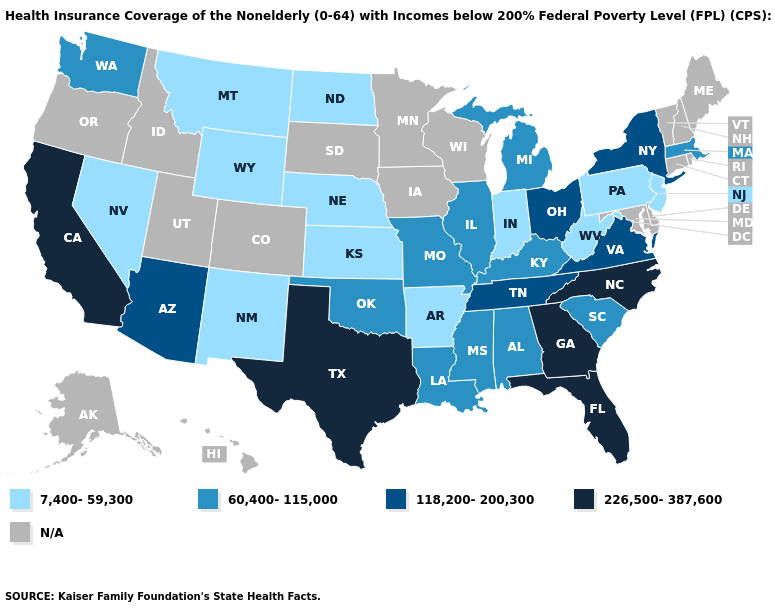Name the states that have a value in the range N/A?
Be succinct. Alaska, Colorado, Connecticut, Delaware, Hawaii, Idaho, Iowa, Maine, Maryland, Minnesota, New Hampshire, Oregon, Rhode Island, South Dakota, Utah, Vermont, Wisconsin. Among the states that border Indiana , does Michigan have the lowest value?
Short answer required. Yes. What is the highest value in states that border Louisiana?
Write a very short answer. 226,500-387,600. Among the states that border Texas , which have the lowest value?
Keep it brief. Arkansas, New Mexico. How many symbols are there in the legend?
Short answer required. 5. How many symbols are there in the legend?
Write a very short answer. 5. What is the value of Pennsylvania?
Be succinct. 7,400-59,300. What is the value of New Mexico?
Short answer required. 7,400-59,300. Name the states that have a value in the range 118,200-200,300?
Quick response, please. Arizona, New York, Ohio, Tennessee, Virginia. What is the value of South Carolina?
Be succinct. 60,400-115,000. What is the value of Alaska?
Concise answer only. N/A. Is the legend a continuous bar?
Give a very brief answer. No. What is the value of Wyoming?
Concise answer only. 7,400-59,300. What is the value of Oregon?
Keep it brief. N/A. 